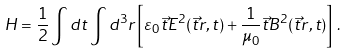<formula> <loc_0><loc_0><loc_500><loc_500>H = \frac { 1 } { 2 } \int d t \int d ^ { 3 } r \left [ \varepsilon _ { 0 } \vec { t } { E } ^ { 2 } ( \vec { t } { r } , t ) + \frac { 1 } { \mu _ { 0 } } \vec { t } { B } ^ { 2 } ( \vec { t } { r } , t ) \right ] \, .</formula> 